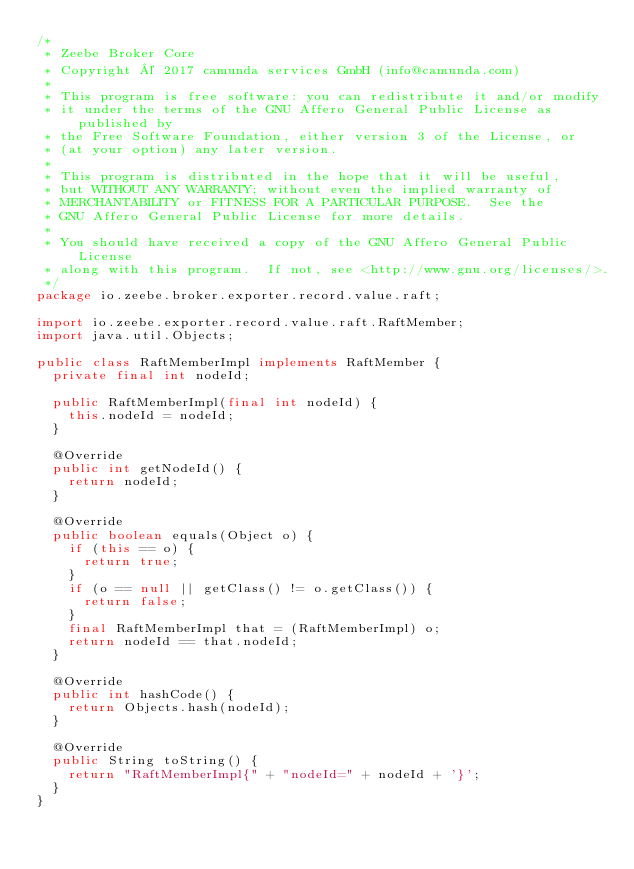Convert code to text. <code><loc_0><loc_0><loc_500><loc_500><_Java_>/*
 * Zeebe Broker Core
 * Copyright © 2017 camunda services GmbH (info@camunda.com)
 *
 * This program is free software: you can redistribute it and/or modify
 * it under the terms of the GNU Affero General Public License as published by
 * the Free Software Foundation, either version 3 of the License, or
 * (at your option) any later version.
 *
 * This program is distributed in the hope that it will be useful,
 * but WITHOUT ANY WARRANTY; without even the implied warranty of
 * MERCHANTABILITY or FITNESS FOR A PARTICULAR PURPOSE.  See the
 * GNU Affero General Public License for more details.
 *
 * You should have received a copy of the GNU Affero General Public License
 * along with this program.  If not, see <http://www.gnu.org/licenses/>.
 */
package io.zeebe.broker.exporter.record.value.raft;

import io.zeebe.exporter.record.value.raft.RaftMember;
import java.util.Objects;

public class RaftMemberImpl implements RaftMember {
  private final int nodeId;

  public RaftMemberImpl(final int nodeId) {
    this.nodeId = nodeId;
  }

  @Override
  public int getNodeId() {
    return nodeId;
  }

  @Override
  public boolean equals(Object o) {
    if (this == o) {
      return true;
    }
    if (o == null || getClass() != o.getClass()) {
      return false;
    }
    final RaftMemberImpl that = (RaftMemberImpl) o;
    return nodeId == that.nodeId;
  }

  @Override
  public int hashCode() {
    return Objects.hash(nodeId);
  }

  @Override
  public String toString() {
    return "RaftMemberImpl{" + "nodeId=" + nodeId + '}';
  }
}
</code> 